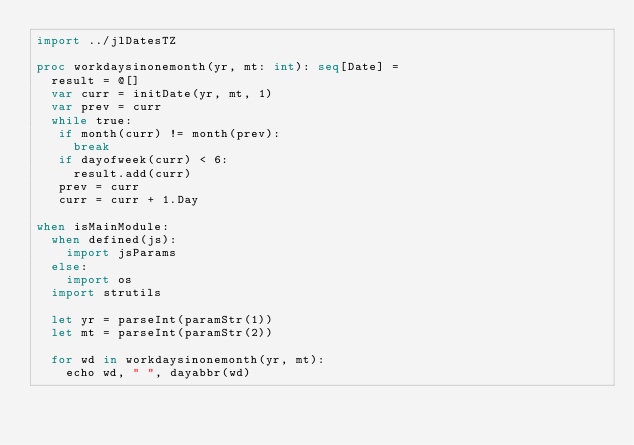<code> <loc_0><loc_0><loc_500><loc_500><_Nim_>import ../jlDatesTZ

proc workdaysinonemonth(yr, mt: int): seq[Date] =
  result = @[]
  var curr = initDate(yr, mt, 1)
  var prev = curr
  while true:
   if month(curr) != month(prev):
     break
   if dayofweek(curr) < 6:
     result.add(curr)
   prev = curr
   curr = curr + 1.Day

when isMainModule:
  when defined(js):
    import jsParams
  else:
    import os
  import strutils

  let yr = parseInt(paramStr(1))
  let mt = parseInt(paramStr(2))

  for wd in workdaysinonemonth(yr, mt):
    echo wd, " ", dayabbr(wd)

</code> 